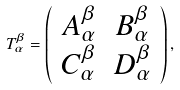Convert formula to latex. <formula><loc_0><loc_0><loc_500><loc_500>T _ { \alpha } ^ { \beta } = \left ( \begin{array} { c c } A _ { \alpha } ^ { \beta } & B _ { \alpha } ^ { \beta } \\ C _ { \alpha } ^ { \beta } & D _ { \alpha } ^ { \beta } \\ \end{array} \right ) ,</formula> 